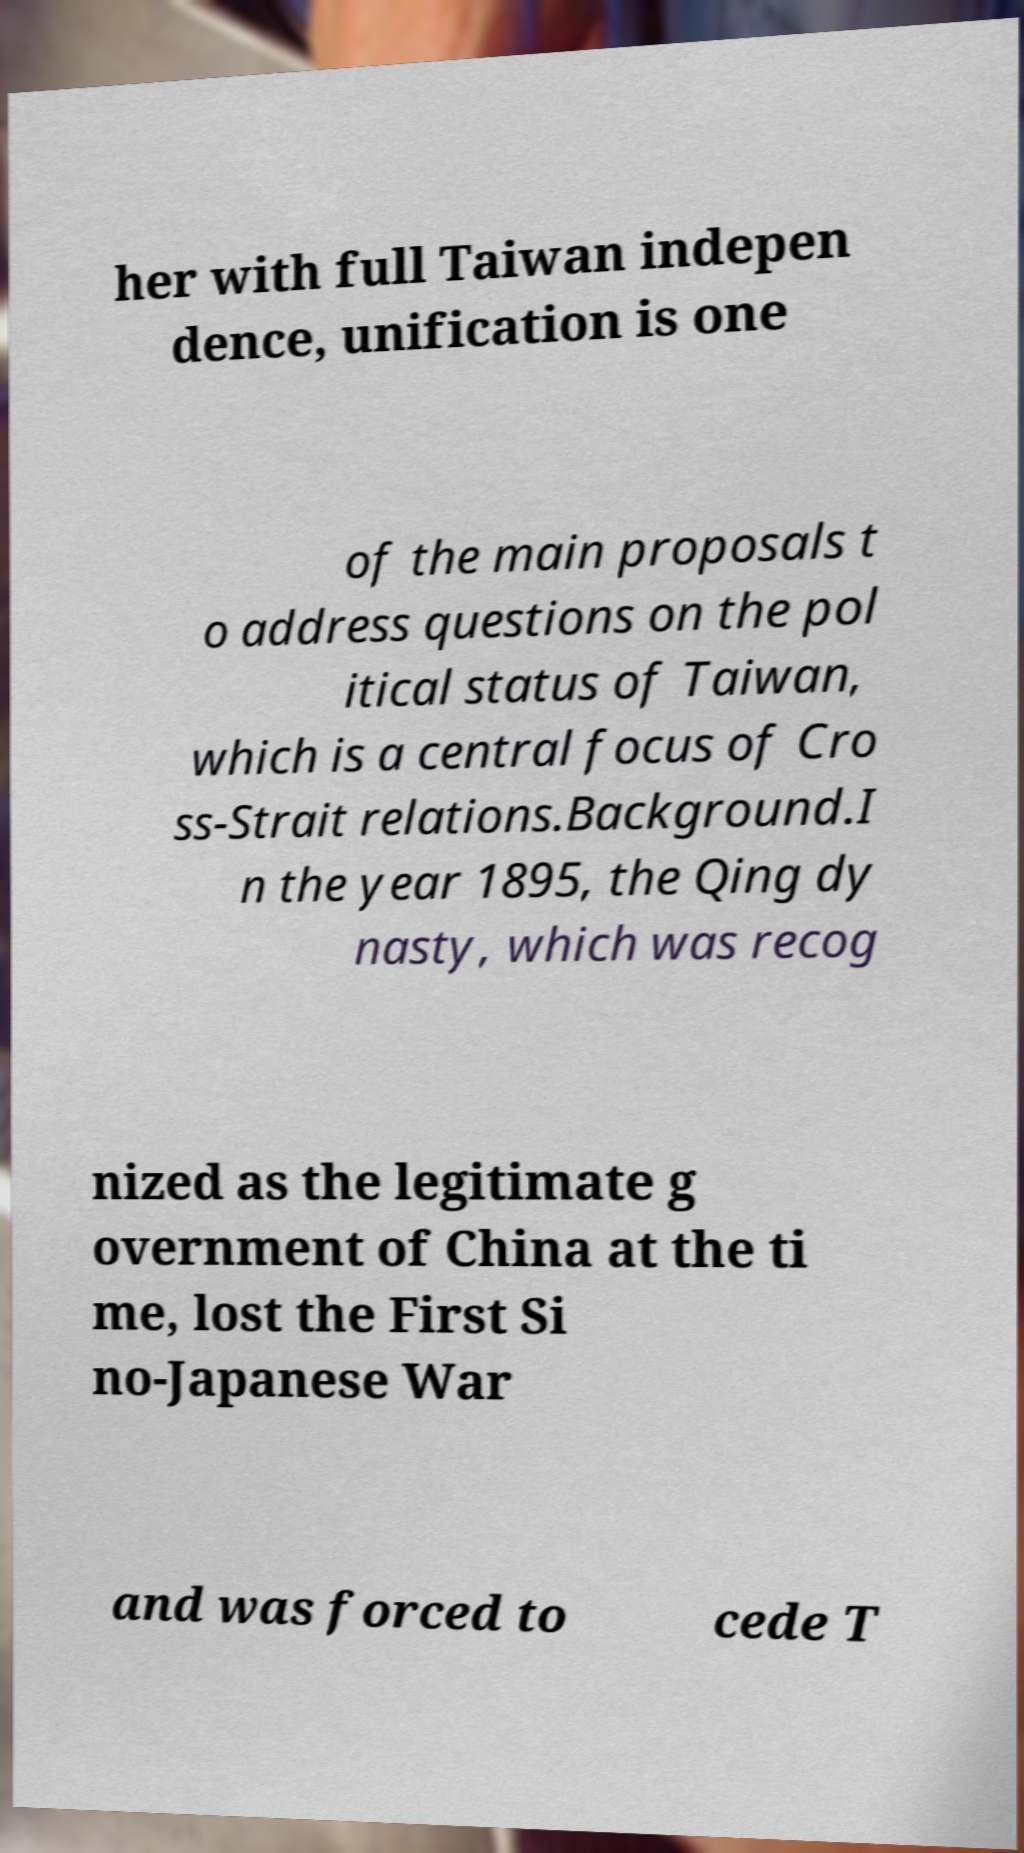Can you accurately transcribe the text from the provided image for me? her with full Taiwan indepen dence, unification is one of the main proposals t o address questions on the pol itical status of Taiwan, which is a central focus of Cro ss-Strait relations.Background.I n the year 1895, the Qing dy nasty, which was recog nized as the legitimate g overnment of China at the ti me, lost the First Si no-Japanese War and was forced to cede T 